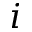<formula> <loc_0><loc_0><loc_500><loc_500>i</formula> 